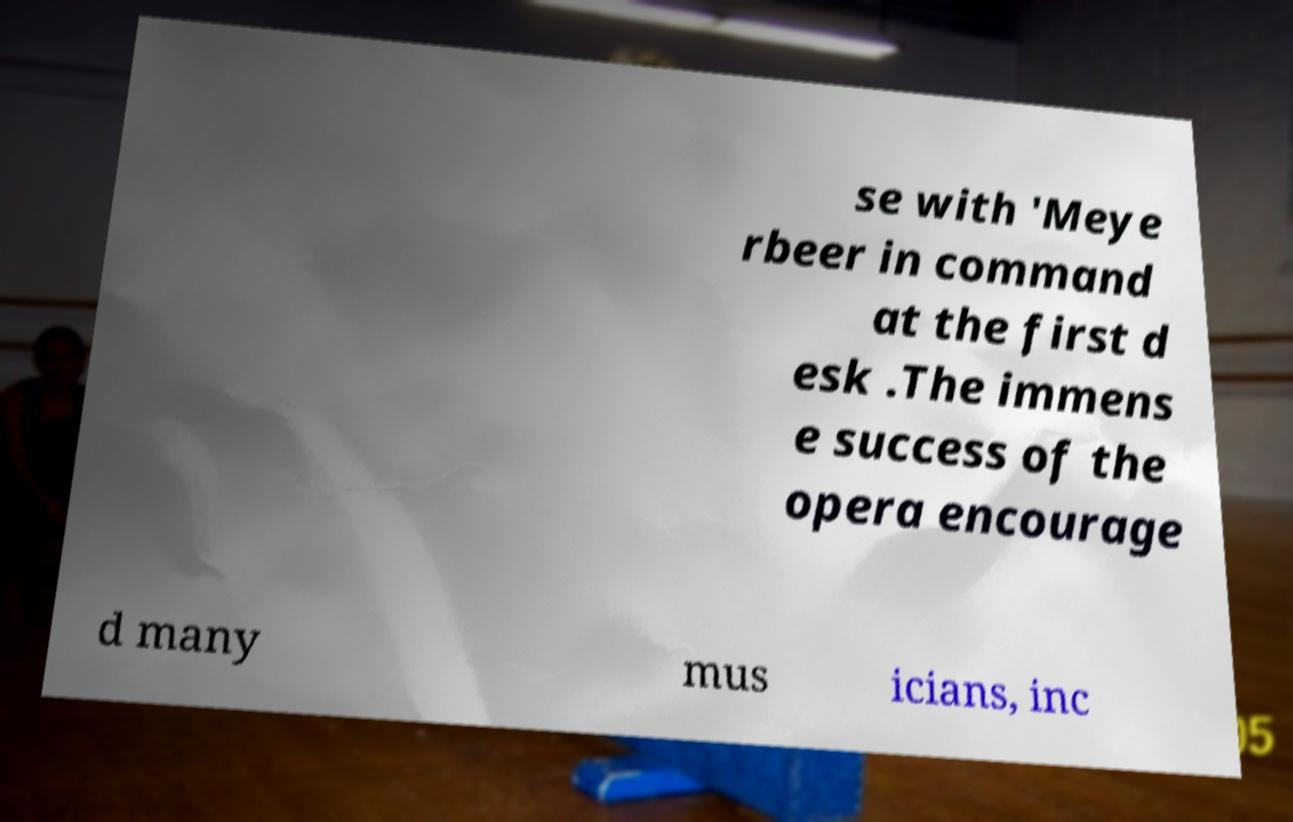Can you read and provide the text displayed in the image?This photo seems to have some interesting text. Can you extract and type it out for me? se with 'Meye rbeer in command at the first d esk .The immens e success of the opera encourage d many mus icians, inc 